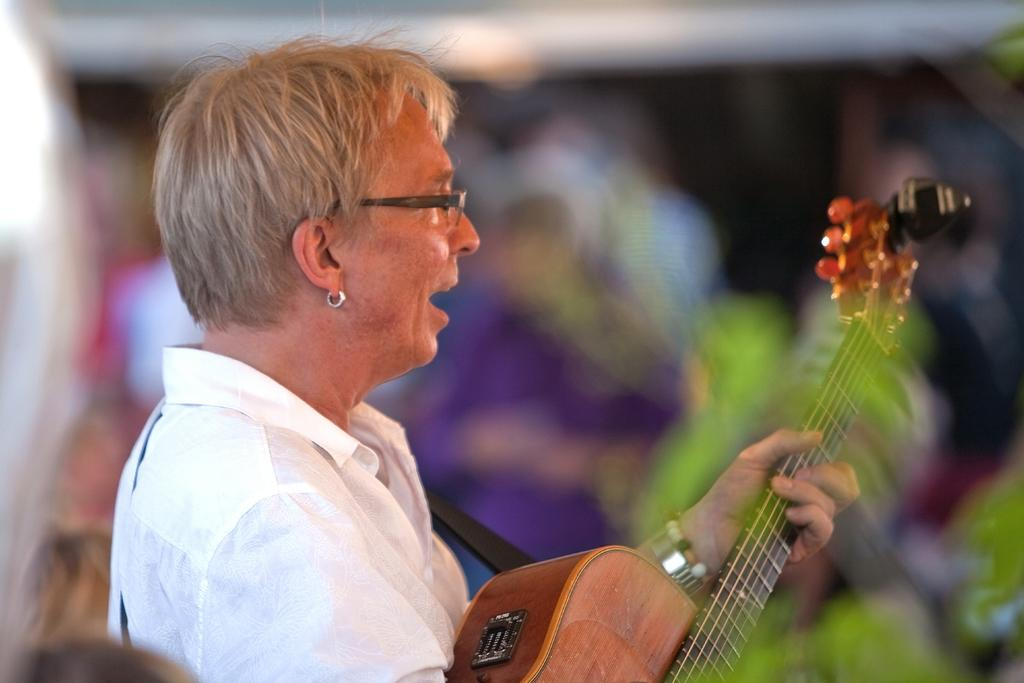Who is the main subject in the image? There is an old woman in the image. What is the old woman holding in the image? The old woman is holding a guitar. What number is written on the top of the guitar in the image? There is no number written on the top of the guitar in the image. 